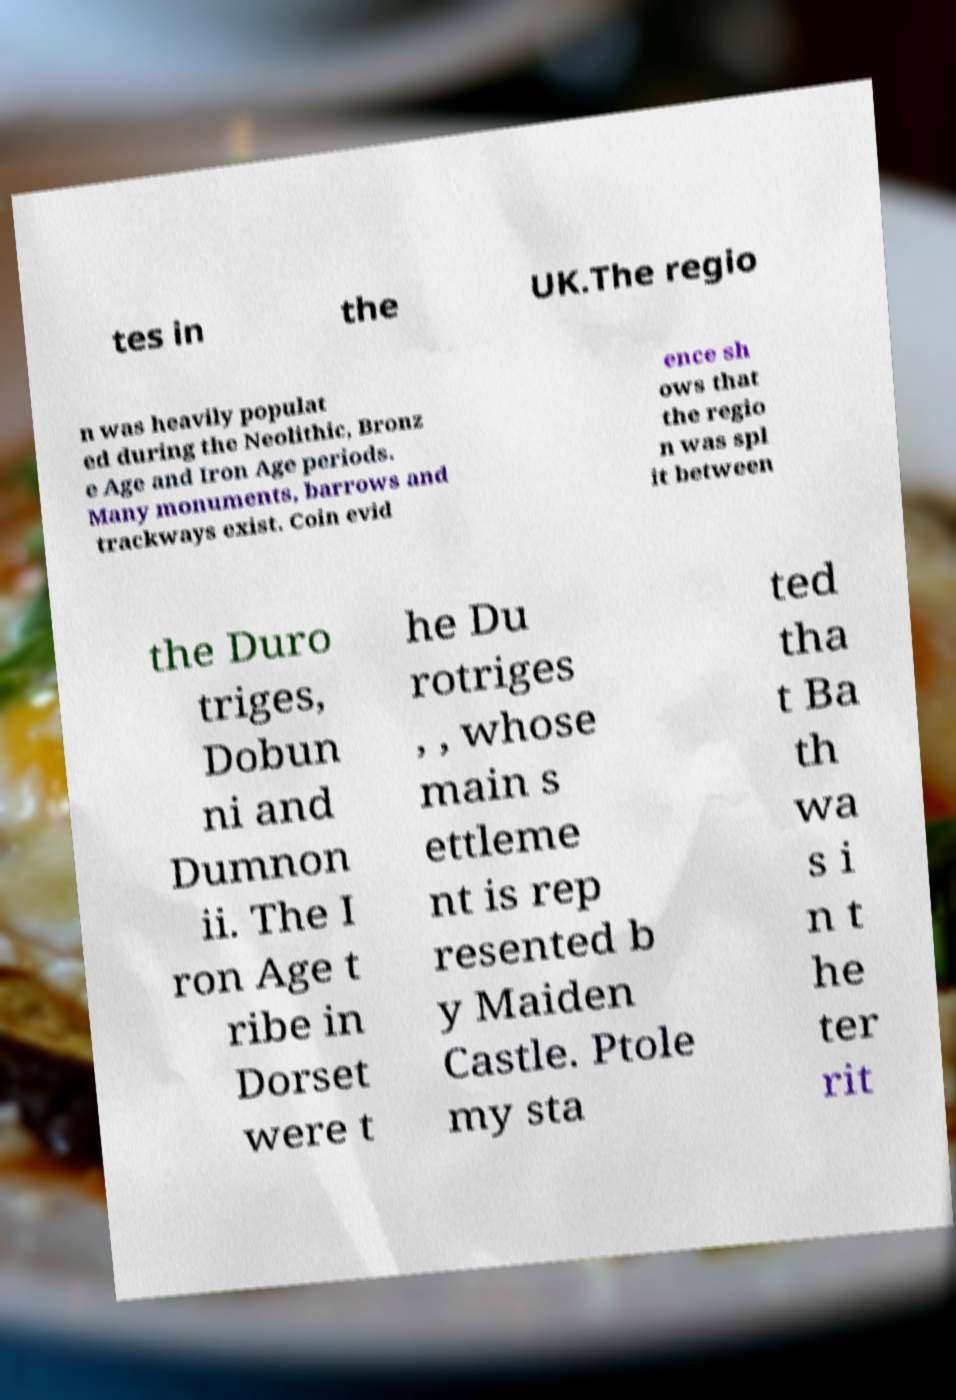Could you assist in decoding the text presented in this image and type it out clearly? tes in the UK.The regio n was heavily populat ed during the Neolithic, Bronz e Age and Iron Age periods. Many monuments, barrows and trackways exist. Coin evid ence sh ows that the regio n was spl it between the Duro triges, Dobun ni and Dumnon ii. The I ron Age t ribe in Dorset were t he Du rotriges , , whose main s ettleme nt is rep resented b y Maiden Castle. Ptole my sta ted tha t Ba th wa s i n t he ter rit 